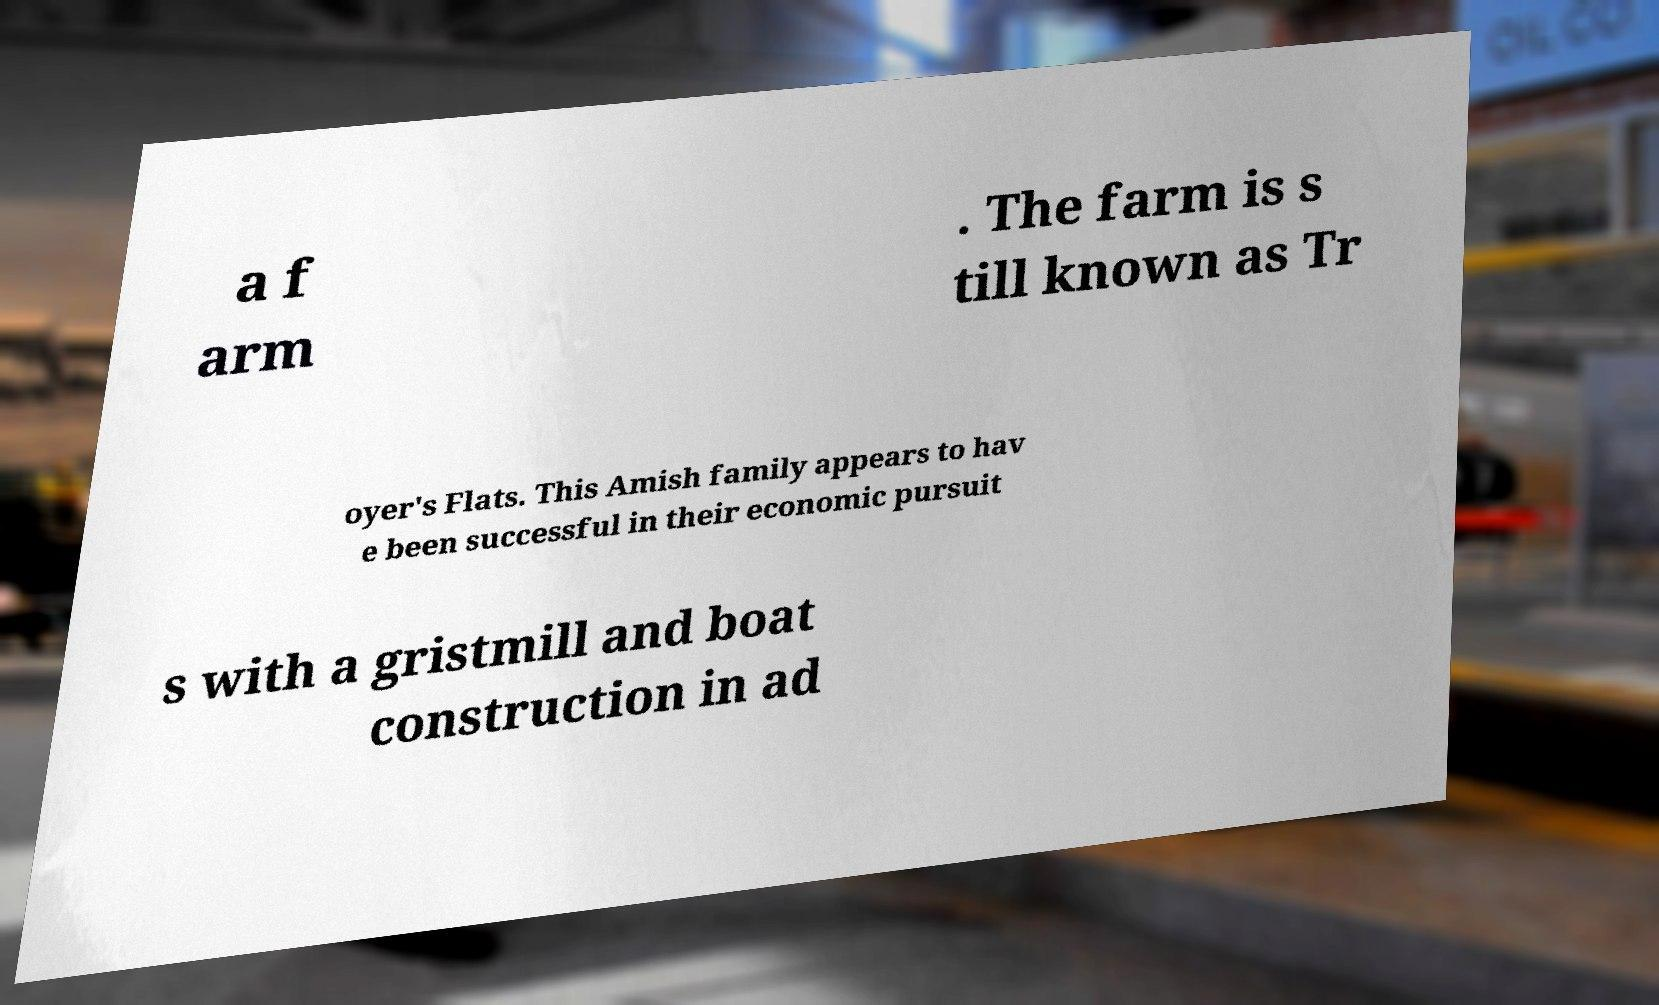Can you read and provide the text displayed in the image?This photo seems to have some interesting text. Can you extract and type it out for me? a f arm . The farm is s till known as Tr oyer's Flats. This Amish family appears to hav e been successful in their economic pursuit s with a gristmill and boat construction in ad 